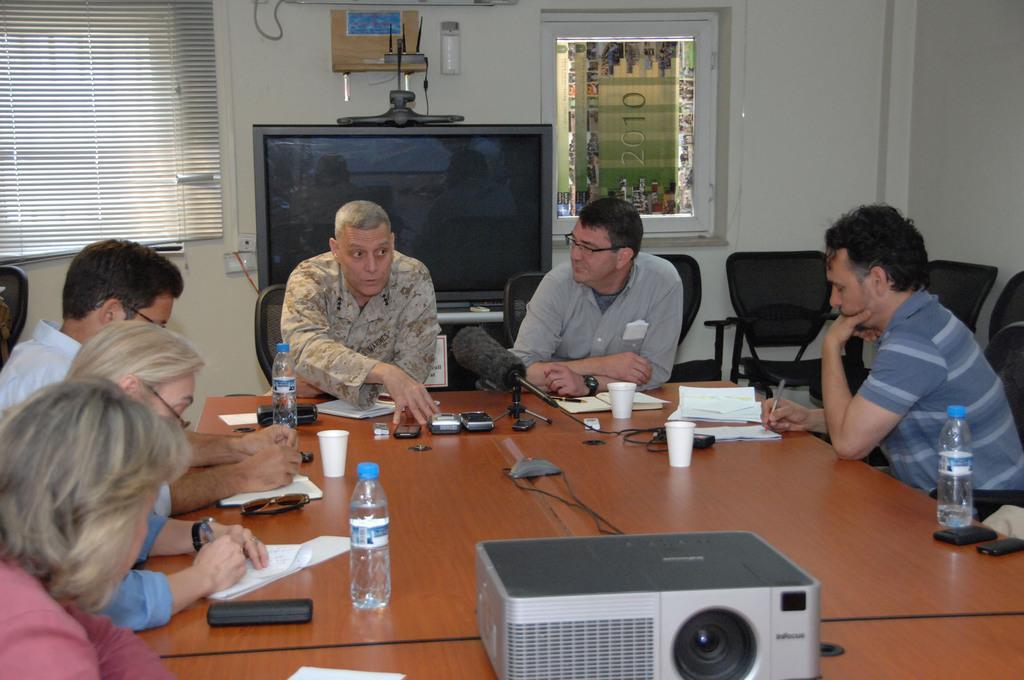Could you give a brief overview of what you see in this image? This image is clicked in a room. There are six persons in this image. In the front, there is a table on which mobiles, mics, papers along with a projector are kept. To the left, the woman is wearing pink shirt. In the background, there is a wall, window along with window blind and a TV. 